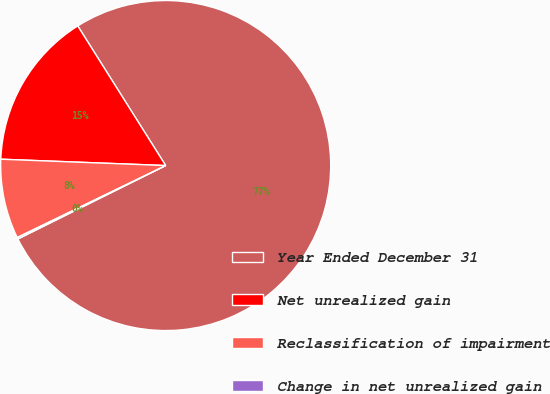Convert chart to OTSL. <chart><loc_0><loc_0><loc_500><loc_500><pie_chart><fcel>Year Ended December 31<fcel>Net unrealized gain<fcel>Reclassification of impairment<fcel>Change in net unrealized gain<nl><fcel>76.61%<fcel>15.44%<fcel>7.8%<fcel>0.15%<nl></chart> 